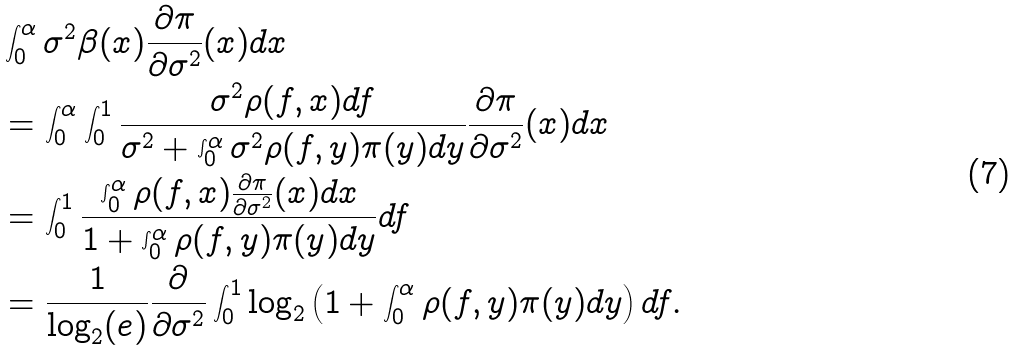<formula> <loc_0><loc_0><loc_500><loc_500>& \int _ { 0 } ^ { \alpha } \sigma ^ { 2 } \beta ( x ) \frac { \partial \pi } { \partial \sigma ^ { 2 } } ( x ) d x \\ & = \int _ { 0 } ^ { \alpha } \int _ { 0 } ^ { 1 } \frac { \sigma ^ { 2 } \rho ( f , x ) d f } { \sigma ^ { 2 } + \int _ { 0 } ^ { \alpha } \sigma ^ { 2 } \rho ( f , y ) \pi ( y ) d y } \frac { \partial \pi } { \partial \sigma ^ { 2 } } ( x ) d x \\ & = \int _ { 0 } ^ { 1 } \frac { \int _ { 0 } ^ { \alpha } \rho ( f , x ) \frac { \partial \pi } { \partial \sigma ^ { 2 } } ( x ) d x } { 1 + \int _ { 0 } ^ { \alpha } \rho ( f , y ) \pi ( y ) d y } d f \\ & = \frac { 1 } { \log _ { 2 } ( e ) } \frac { \partial } { \partial \sigma ^ { 2 } } \int _ { 0 } ^ { 1 } \log _ { 2 } \left ( 1 + \int _ { 0 } ^ { \alpha } \rho ( f , y ) \pi ( y ) d y \right ) d f .</formula> 